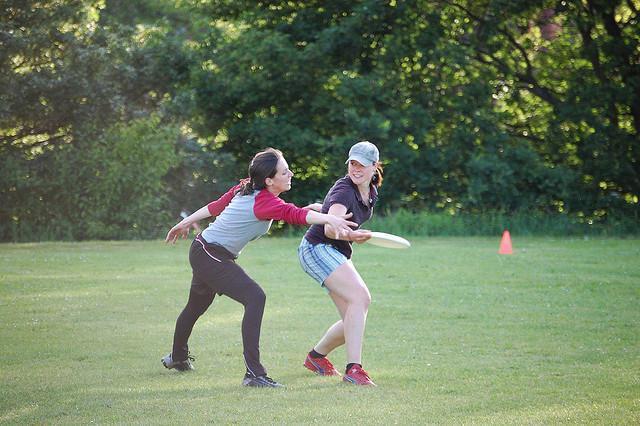How many orange cones are visible?
Give a very brief answer. 1. How many people are posing for the picture?
Give a very brief answer. 2. How many people are visible?
Give a very brief answer. 2. 